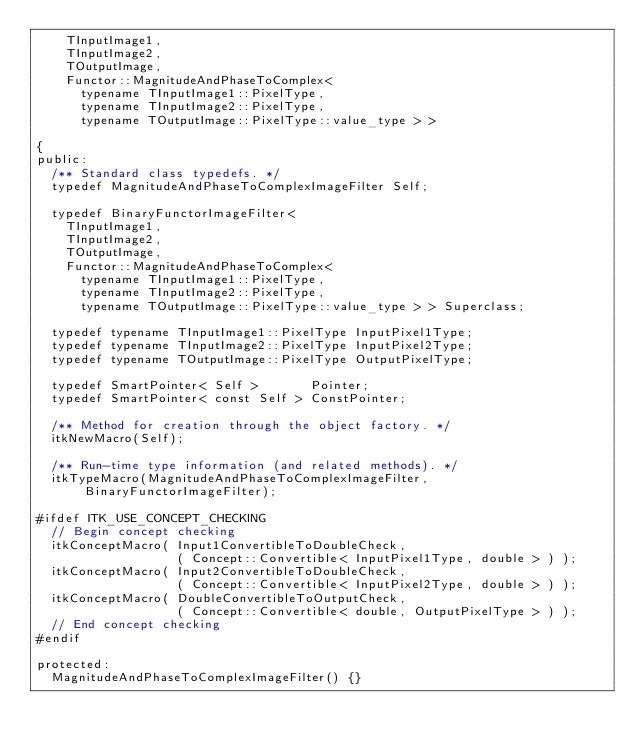Convert code to text. <code><loc_0><loc_0><loc_500><loc_500><_C_>    TInputImage1,
    TInputImage2,
    TOutputImage,
    Functor::MagnitudeAndPhaseToComplex<
      typename TInputImage1::PixelType,
      typename TInputImage2::PixelType,
      typename TOutputImage::PixelType::value_type > >

{
public:
  /** Standard class typedefs. */
  typedef MagnitudeAndPhaseToComplexImageFilter Self;

  typedef BinaryFunctorImageFilter<
    TInputImage1,
    TInputImage2,
    TOutputImage,
    Functor::MagnitudeAndPhaseToComplex<
      typename TInputImage1::PixelType,
      typename TInputImage2::PixelType,
      typename TOutputImage::PixelType::value_type > > Superclass;

  typedef typename TInputImage1::PixelType InputPixel1Type;
  typedef typename TInputImage2::PixelType InputPixel2Type;
  typedef typename TOutputImage::PixelType OutputPixelType;

  typedef SmartPointer< Self >       Pointer;
  typedef SmartPointer< const Self > ConstPointer;

  /** Method for creation through the object factory. */
  itkNewMacro(Self);

  /** Run-time type information (and related methods). */
  itkTypeMacro(MagnitudeAndPhaseToComplexImageFilter, BinaryFunctorImageFilter);

#ifdef ITK_USE_CONCEPT_CHECKING
  // Begin concept checking
  itkConceptMacro( Input1ConvertibleToDoubleCheck,
                   ( Concept::Convertible< InputPixel1Type, double > ) );
  itkConceptMacro( Input2ConvertibleToDoubleCheck,
                   ( Concept::Convertible< InputPixel2Type, double > ) );
  itkConceptMacro( DoubleConvertibleToOutputCheck,
                   ( Concept::Convertible< double, OutputPixelType > ) );
  // End concept checking
#endif

protected:
  MagnitudeAndPhaseToComplexImageFilter() {}</code> 